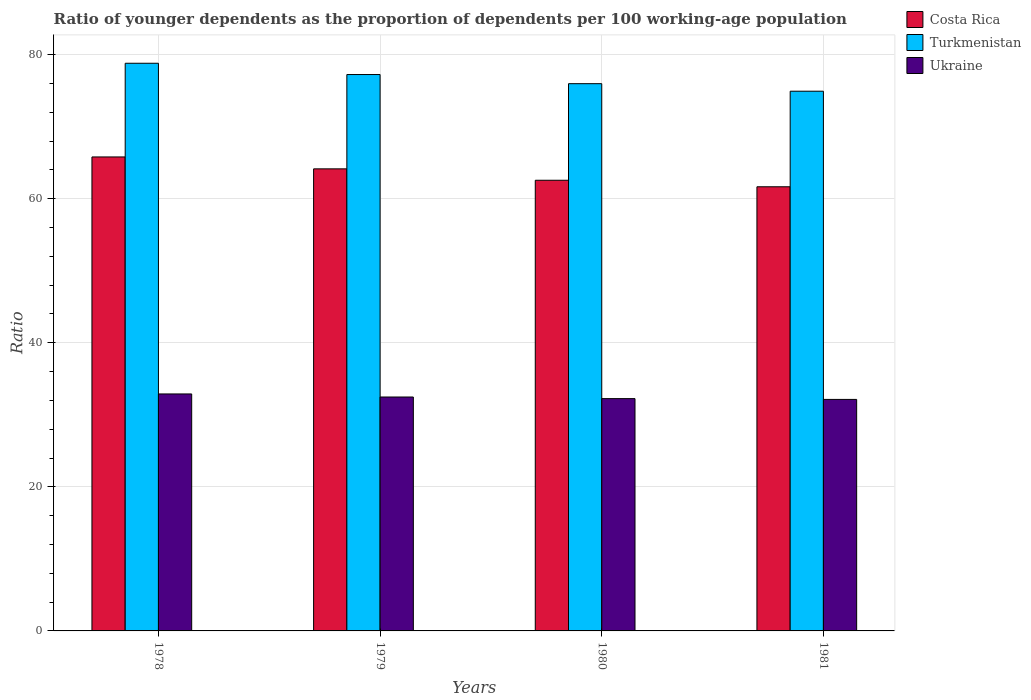How many different coloured bars are there?
Your answer should be compact. 3. How many groups of bars are there?
Provide a short and direct response. 4. Are the number of bars per tick equal to the number of legend labels?
Provide a short and direct response. Yes. Are the number of bars on each tick of the X-axis equal?
Provide a short and direct response. Yes. How many bars are there on the 4th tick from the left?
Your answer should be very brief. 3. What is the label of the 2nd group of bars from the left?
Your answer should be compact. 1979. In how many cases, is the number of bars for a given year not equal to the number of legend labels?
Your answer should be compact. 0. What is the age dependency ratio(young) in Turkmenistan in 1979?
Give a very brief answer. 77.24. Across all years, what is the maximum age dependency ratio(young) in Costa Rica?
Your response must be concise. 65.8. Across all years, what is the minimum age dependency ratio(young) in Costa Rica?
Make the answer very short. 61.66. In which year was the age dependency ratio(young) in Costa Rica maximum?
Your answer should be compact. 1978. In which year was the age dependency ratio(young) in Turkmenistan minimum?
Make the answer very short. 1981. What is the total age dependency ratio(young) in Turkmenistan in the graph?
Your response must be concise. 306.95. What is the difference between the age dependency ratio(young) in Ukraine in 1978 and that in 1981?
Your answer should be very brief. 0.76. What is the difference between the age dependency ratio(young) in Costa Rica in 1981 and the age dependency ratio(young) in Turkmenistan in 1980?
Offer a very short reply. -14.31. What is the average age dependency ratio(young) in Ukraine per year?
Keep it short and to the point. 32.44. In the year 1980, what is the difference between the age dependency ratio(young) in Costa Rica and age dependency ratio(young) in Ukraine?
Offer a terse response. 30.32. In how many years, is the age dependency ratio(young) in Costa Rica greater than 4?
Ensure brevity in your answer.  4. What is the ratio of the age dependency ratio(young) in Costa Rica in 1978 to that in 1980?
Your answer should be very brief. 1.05. What is the difference between the highest and the second highest age dependency ratio(young) in Turkmenistan?
Ensure brevity in your answer.  1.57. What is the difference between the highest and the lowest age dependency ratio(young) in Turkmenistan?
Offer a terse response. 3.88. In how many years, is the age dependency ratio(young) in Ukraine greater than the average age dependency ratio(young) in Ukraine taken over all years?
Your response must be concise. 2. What does the 3rd bar from the left in 1978 represents?
Give a very brief answer. Ukraine. What does the 2nd bar from the right in 1979 represents?
Your response must be concise. Turkmenistan. How many bars are there?
Your response must be concise. 12. Are all the bars in the graph horizontal?
Your answer should be very brief. No. How many years are there in the graph?
Give a very brief answer. 4. What is the difference between two consecutive major ticks on the Y-axis?
Make the answer very short. 20. Does the graph contain any zero values?
Keep it short and to the point. No. Does the graph contain grids?
Keep it short and to the point. Yes. Where does the legend appear in the graph?
Your answer should be very brief. Top right. How are the legend labels stacked?
Provide a succinct answer. Vertical. What is the title of the graph?
Your answer should be compact. Ratio of younger dependents as the proportion of dependents per 100 working-age population. What is the label or title of the X-axis?
Ensure brevity in your answer.  Years. What is the label or title of the Y-axis?
Your answer should be compact. Ratio. What is the Ratio of Costa Rica in 1978?
Your answer should be compact. 65.8. What is the Ratio in Turkmenistan in 1978?
Make the answer very short. 78.81. What is the Ratio of Ukraine in 1978?
Your response must be concise. 32.9. What is the Ratio in Costa Rica in 1979?
Give a very brief answer. 64.15. What is the Ratio of Turkmenistan in 1979?
Keep it short and to the point. 77.24. What is the Ratio of Ukraine in 1979?
Give a very brief answer. 32.47. What is the Ratio of Costa Rica in 1980?
Ensure brevity in your answer.  62.56. What is the Ratio in Turkmenistan in 1980?
Keep it short and to the point. 75.97. What is the Ratio in Ukraine in 1980?
Offer a very short reply. 32.25. What is the Ratio of Costa Rica in 1981?
Ensure brevity in your answer.  61.66. What is the Ratio in Turkmenistan in 1981?
Keep it short and to the point. 74.93. What is the Ratio in Ukraine in 1981?
Your response must be concise. 32.14. Across all years, what is the maximum Ratio of Costa Rica?
Make the answer very short. 65.8. Across all years, what is the maximum Ratio in Turkmenistan?
Offer a very short reply. 78.81. Across all years, what is the maximum Ratio in Ukraine?
Ensure brevity in your answer.  32.9. Across all years, what is the minimum Ratio in Costa Rica?
Your response must be concise. 61.66. Across all years, what is the minimum Ratio of Turkmenistan?
Your answer should be very brief. 74.93. Across all years, what is the minimum Ratio of Ukraine?
Ensure brevity in your answer.  32.14. What is the total Ratio of Costa Rica in the graph?
Keep it short and to the point. 254.17. What is the total Ratio in Turkmenistan in the graph?
Your response must be concise. 306.95. What is the total Ratio in Ukraine in the graph?
Make the answer very short. 129.76. What is the difference between the Ratio in Costa Rica in 1978 and that in 1979?
Your answer should be very brief. 1.65. What is the difference between the Ratio in Turkmenistan in 1978 and that in 1979?
Give a very brief answer. 1.57. What is the difference between the Ratio in Ukraine in 1978 and that in 1979?
Provide a short and direct response. 0.43. What is the difference between the Ratio in Costa Rica in 1978 and that in 1980?
Your answer should be compact. 3.24. What is the difference between the Ratio of Turkmenistan in 1978 and that in 1980?
Make the answer very short. 2.83. What is the difference between the Ratio in Ukraine in 1978 and that in 1980?
Your answer should be very brief. 0.65. What is the difference between the Ratio of Costa Rica in 1978 and that in 1981?
Make the answer very short. 4.14. What is the difference between the Ratio in Turkmenistan in 1978 and that in 1981?
Your answer should be compact. 3.88. What is the difference between the Ratio in Ukraine in 1978 and that in 1981?
Your answer should be compact. 0.76. What is the difference between the Ratio of Costa Rica in 1979 and that in 1980?
Ensure brevity in your answer.  1.58. What is the difference between the Ratio of Turkmenistan in 1979 and that in 1980?
Ensure brevity in your answer.  1.27. What is the difference between the Ratio of Ukraine in 1979 and that in 1980?
Ensure brevity in your answer.  0.22. What is the difference between the Ratio in Costa Rica in 1979 and that in 1981?
Your response must be concise. 2.49. What is the difference between the Ratio of Turkmenistan in 1979 and that in 1981?
Your response must be concise. 2.31. What is the difference between the Ratio of Ukraine in 1979 and that in 1981?
Your answer should be very brief. 0.33. What is the difference between the Ratio in Costa Rica in 1980 and that in 1981?
Ensure brevity in your answer.  0.9. What is the difference between the Ratio of Turkmenistan in 1980 and that in 1981?
Keep it short and to the point. 1.05. What is the difference between the Ratio of Ukraine in 1980 and that in 1981?
Provide a succinct answer. 0.11. What is the difference between the Ratio in Costa Rica in 1978 and the Ratio in Turkmenistan in 1979?
Your response must be concise. -11.44. What is the difference between the Ratio in Costa Rica in 1978 and the Ratio in Ukraine in 1979?
Your answer should be compact. 33.33. What is the difference between the Ratio in Turkmenistan in 1978 and the Ratio in Ukraine in 1979?
Offer a very short reply. 46.33. What is the difference between the Ratio of Costa Rica in 1978 and the Ratio of Turkmenistan in 1980?
Your answer should be very brief. -10.17. What is the difference between the Ratio of Costa Rica in 1978 and the Ratio of Ukraine in 1980?
Your response must be concise. 33.55. What is the difference between the Ratio in Turkmenistan in 1978 and the Ratio in Ukraine in 1980?
Offer a very short reply. 46.56. What is the difference between the Ratio in Costa Rica in 1978 and the Ratio in Turkmenistan in 1981?
Ensure brevity in your answer.  -9.13. What is the difference between the Ratio in Costa Rica in 1978 and the Ratio in Ukraine in 1981?
Offer a very short reply. 33.66. What is the difference between the Ratio in Turkmenistan in 1978 and the Ratio in Ukraine in 1981?
Provide a short and direct response. 46.67. What is the difference between the Ratio of Costa Rica in 1979 and the Ratio of Turkmenistan in 1980?
Keep it short and to the point. -11.83. What is the difference between the Ratio of Costa Rica in 1979 and the Ratio of Ukraine in 1980?
Provide a succinct answer. 31.9. What is the difference between the Ratio of Turkmenistan in 1979 and the Ratio of Ukraine in 1980?
Provide a succinct answer. 44.99. What is the difference between the Ratio of Costa Rica in 1979 and the Ratio of Turkmenistan in 1981?
Make the answer very short. -10.78. What is the difference between the Ratio of Costa Rica in 1979 and the Ratio of Ukraine in 1981?
Keep it short and to the point. 32.01. What is the difference between the Ratio in Turkmenistan in 1979 and the Ratio in Ukraine in 1981?
Provide a succinct answer. 45.1. What is the difference between the Ratio in Costa Rica in 1980 and the Ratio in Turkmenistan in 1981?
Your answer should be very brief. -12.36. What is the difference between the Ratio in Costa Rica in 1980 and the Ratio in Ukraine in 1981?
Provide a succinct answer. 30.42. What is the difference between the Ratio in Turkmenistan in 1980 and the Ratio in Ukraine in 1981?
Ensure brevity in your answer.  43.83. What is the average Ratio in Costa Rica per year?
Make the answer very short. 63.54. What is the average Ratio in Turkmenistan per year?
Provide a short and direct response. 76.74. What is the average Ratio in Ukraine per year?
Ensure brevity in your answer.  32.44. In the year 1978, what is the difference between the Ratio in Costa Rica and Ratio in Turkmenistan?
Keep it short and to the point. -13.01. In the year 1978, what is the difference between the Ratio in Costa Rica and Ratio in Ukraine?
Offer a terse response. 32.9. In the year 1978, what is the difference between the Ratio in Turkmenistan and Ratio in Ukraine?
Provide a short and direct response. 45.91. In the year 1979, what is the difference between the Ratio of Costa Rica and Ratio of Turkmenistan?
Give a very brief answer. -13.09. In the year 1979, what is the difference between the Ratio of Costa Rica and Ratio of Ukraine?
Provide a short and direct response. 31.67. In the year 1979, what is the difference between the Ratio of Turkmenistan and Ratio of Ukraine?
Your response must be concise. 44.77. In the year 1980, what is the difference between the Ratio of Costa Rica and Ratio of Turkmenistan?
Your answer should be compact. -13.41. In the year 1980, what is the difference between the Ratio in Costa Rica and Ratio in Ukraine?
Give a very brief answer. 30.32. In the year 1980, what is the difference between the Ratio of Turkmenistan and Ratio of Ukraine?
Your answer should be compact. 43.72. In the year 1981, what is the difference between the Ratio in Costa Rica and Ratio in Turkmenistan?
Keep it short and to the point. -13.27. In the year 1981, what is the difference between the Ratio in Costa Rica and Ratio in Ukraine?
Offer a very short reply. 29.52. In the year 1981, what is the difference between the Ratio in Turkmenistan and Ratio in Ukraine?
Your answer should be compact. 42.79. What is the ratio of the Ratio in Costa Rica in 1978 to that in 1979?
Provide a succinct answer. 1.03. What is the ratio of the Ratio of Turkmenistan in 1978 to that in 1979?
Offer a terse response. 1.02. What is the ratio of the Ratio in Ukraine in 1978 to that in 1979?
Provide a succinct answer. 1.01. What is the ratio of the Ratio of Costa Rica in 1978 to that in 1980?
Make the answer very short. 1.05. What is the ratio of the Ratio in Turkmenistan in 1978 to that in 1980?
Give a very brief answer. 1.04. What is the ratio of the Ratio in Ukraine in 1978 to that in 1980?
Provide a short and direct response. 1.02. What is the ratio of the Ratio of Costa Rica in 1978 to that in 1981?
Your answer should be compact. 1.07. What is the ratio of the Ratio in Turkmenistan in 1978 to that in 1981?
Offer a terse response. 1.05. What is the ratio of the Ratio in Ukraine in 1978 to that in 1981?
Your response must be concise. 1.02. What is the ratio of the Ratio of Costa Rica in 1979 to that in 1980?
Offer a very short reply. 1.03. What is the ratio of the Ratio in Turkmenistan in 1979 to that in 1980?
Provide a succinct answer. 1.02. What is the ratio of the Ratio in Costa Rica in 1979 to that in 1981?
Give a very brief answer. 1.04. What is the ratio of the Ratio in Turkmenistan in 1979 to that in 1981?
Offer a terse response. 1.03. What is the ratio of the Ratio of Ukraine in 1979 to that in 1981?
Offer a terse response. 1.01. What is the ratio of the Ratio of Costa Rica in 1980 to that in 1981?
Give a very brief answer. 1.01. What is the ratio of the Ratio in Turkmenistan in 1980 to that in 1981?
Your answer should be very brief. 1.01. What is the difference between the highest and the second highest Ratio of Costa Rica?
Ensure brevity in your answer.  1.65. What is the difference between the highest and the second highest Ratio in Turkmenistan?
Provide a short and direct response. 1.57. What is the difference between the highest and the second highest Ratio in Ukraine?
Provide a short and direct response. 0.43. What is the difference between the highest and the lowest Ratio of Costa Rica?
Your answer should be compact. 4.14. What is the difference between the highest and the lowest Ratio in Turkmenistan?
Give a very brief answer. 3.88. What is the difference between the highest and the lowest Ratio in Ukraine?
Your answer should be compact. 0.76. 